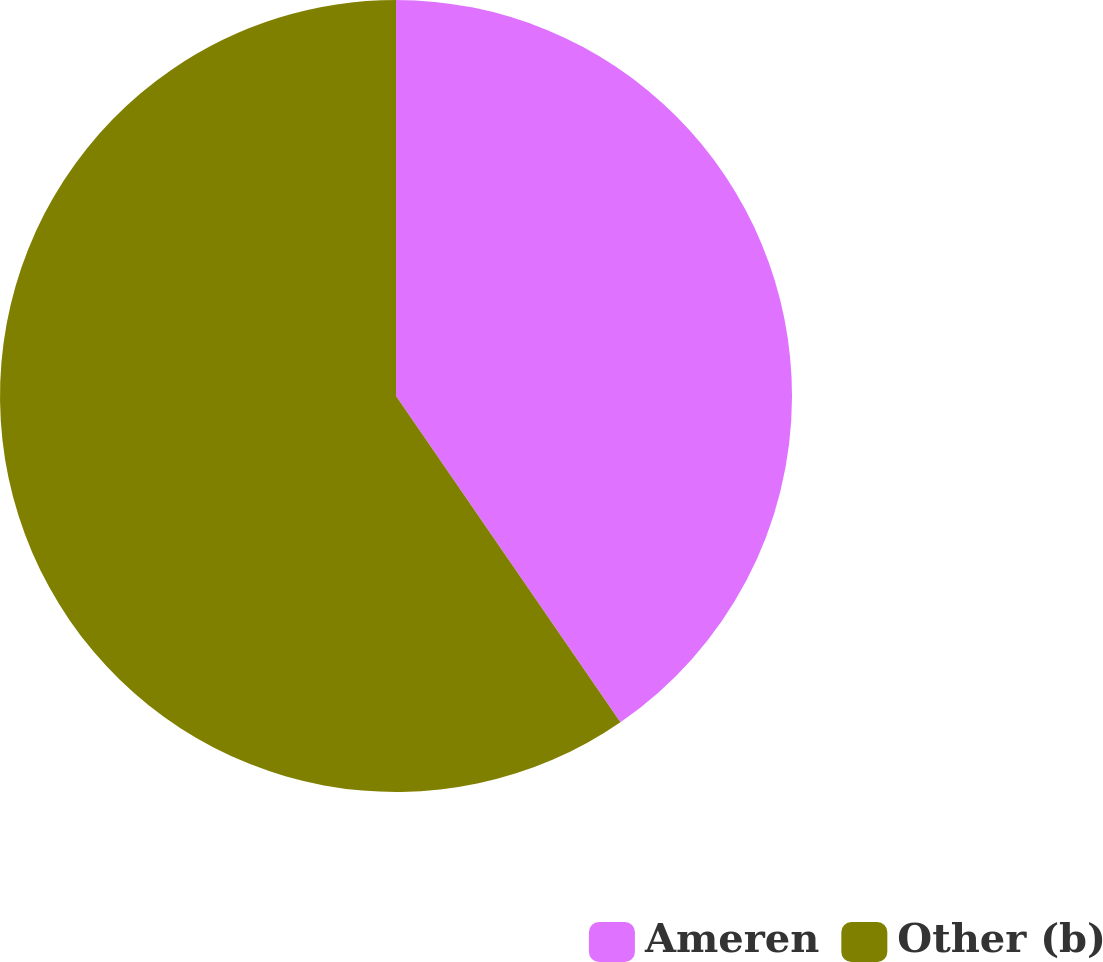<chart> <loc_0><loc_0><loc_500><loc_500><pie_chart><fcel>Ameren<fcel>Other (b)<nl><fcel>40.41%<fcel>59.59%<nl></chart> 